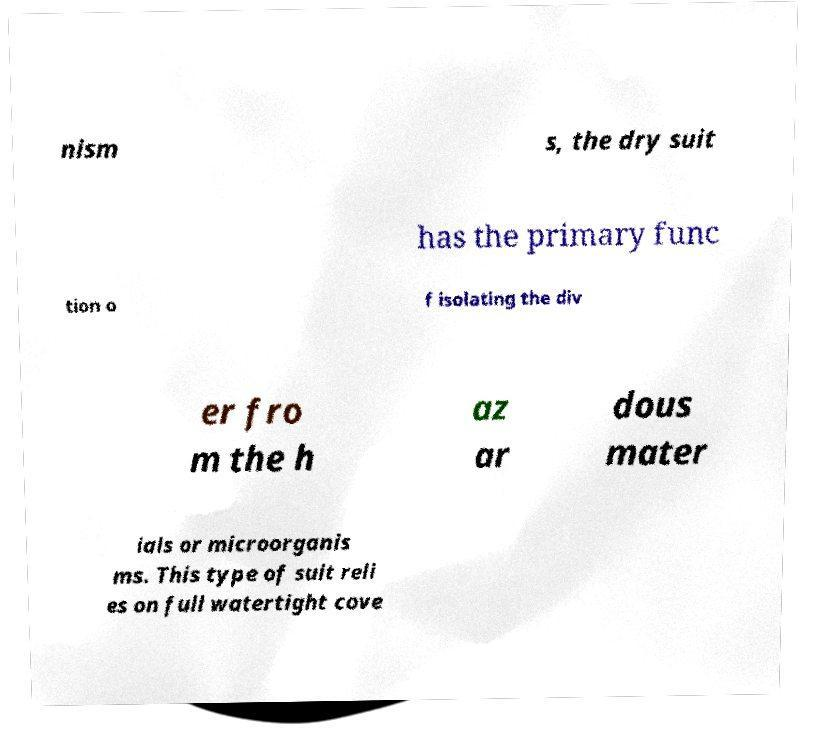I need the written content from this picture converted into text. Can you do that? nism s, the dry suit has the primary func tion o f isolating the div er fro m the h az ar dous mater ials or microorganis ms. This type of suit reli es on full watertight cove 